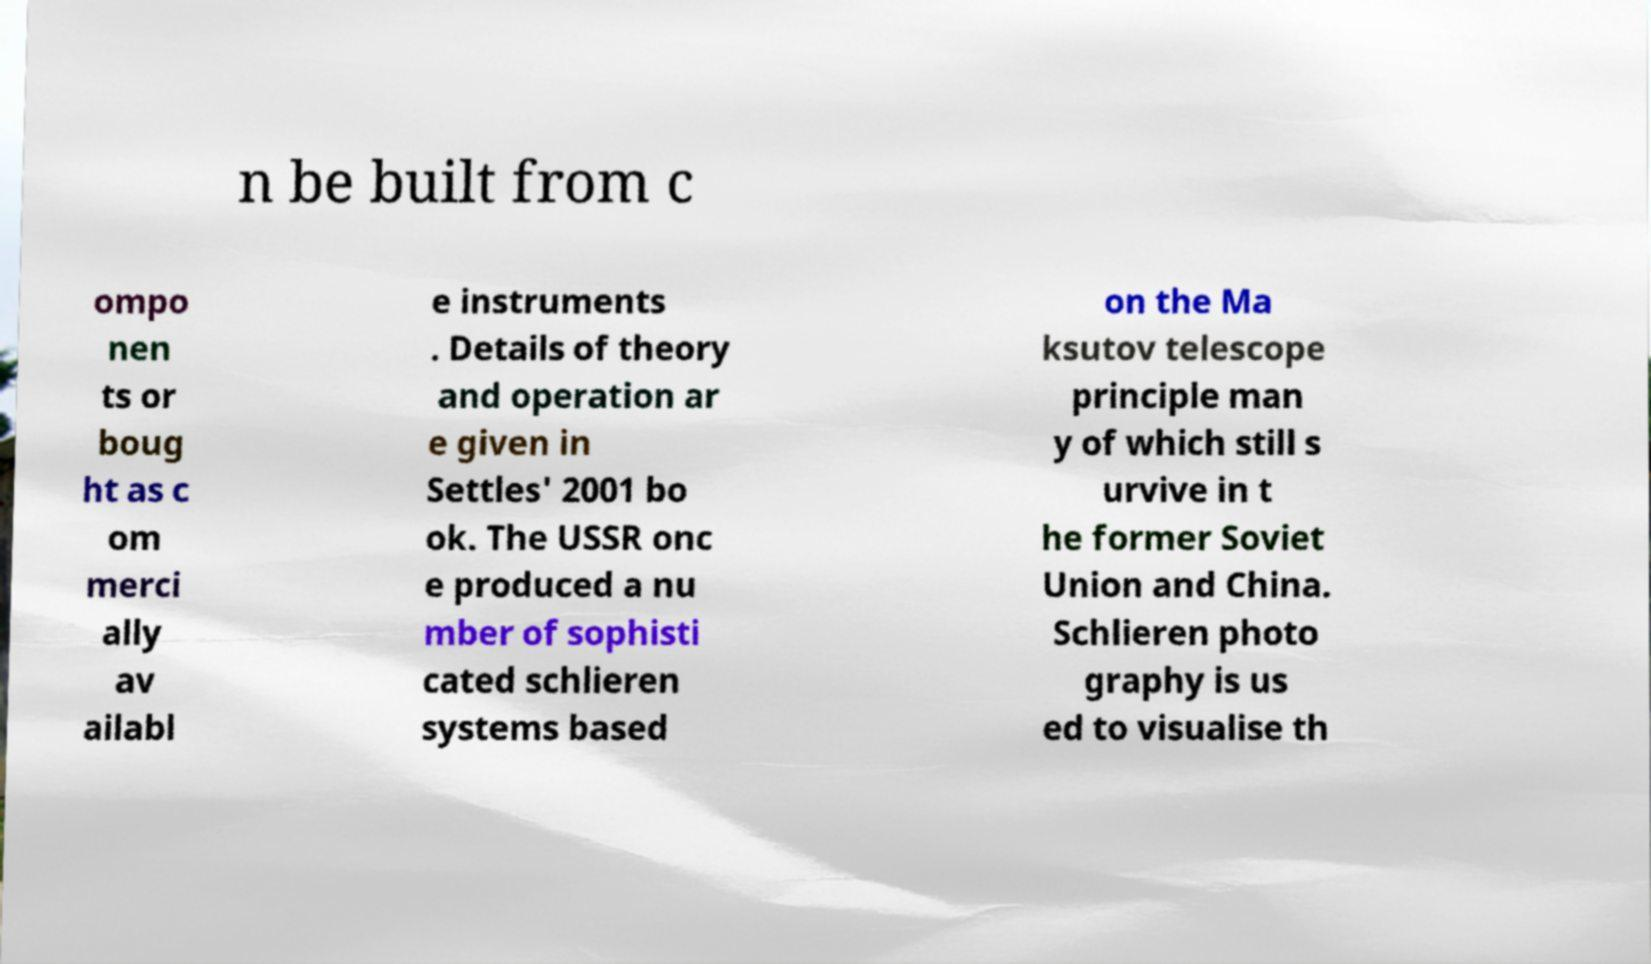For documentation purposes, I need the text within this image transcribed. Could you provide that? n be built from c ompo nen ts or boug ht as c om merci ally av ailabl e instruments . Details of theory and operation ar e given in Settles' 2001 bo ok. The USSR onc e produced a nu mber of sophisti cated schlieren systems based on the Ma ksutov telescope principle man y of which still s urvive in t he former Soviet Union and China. Schlieren photo graphy is us ed to visualise th 